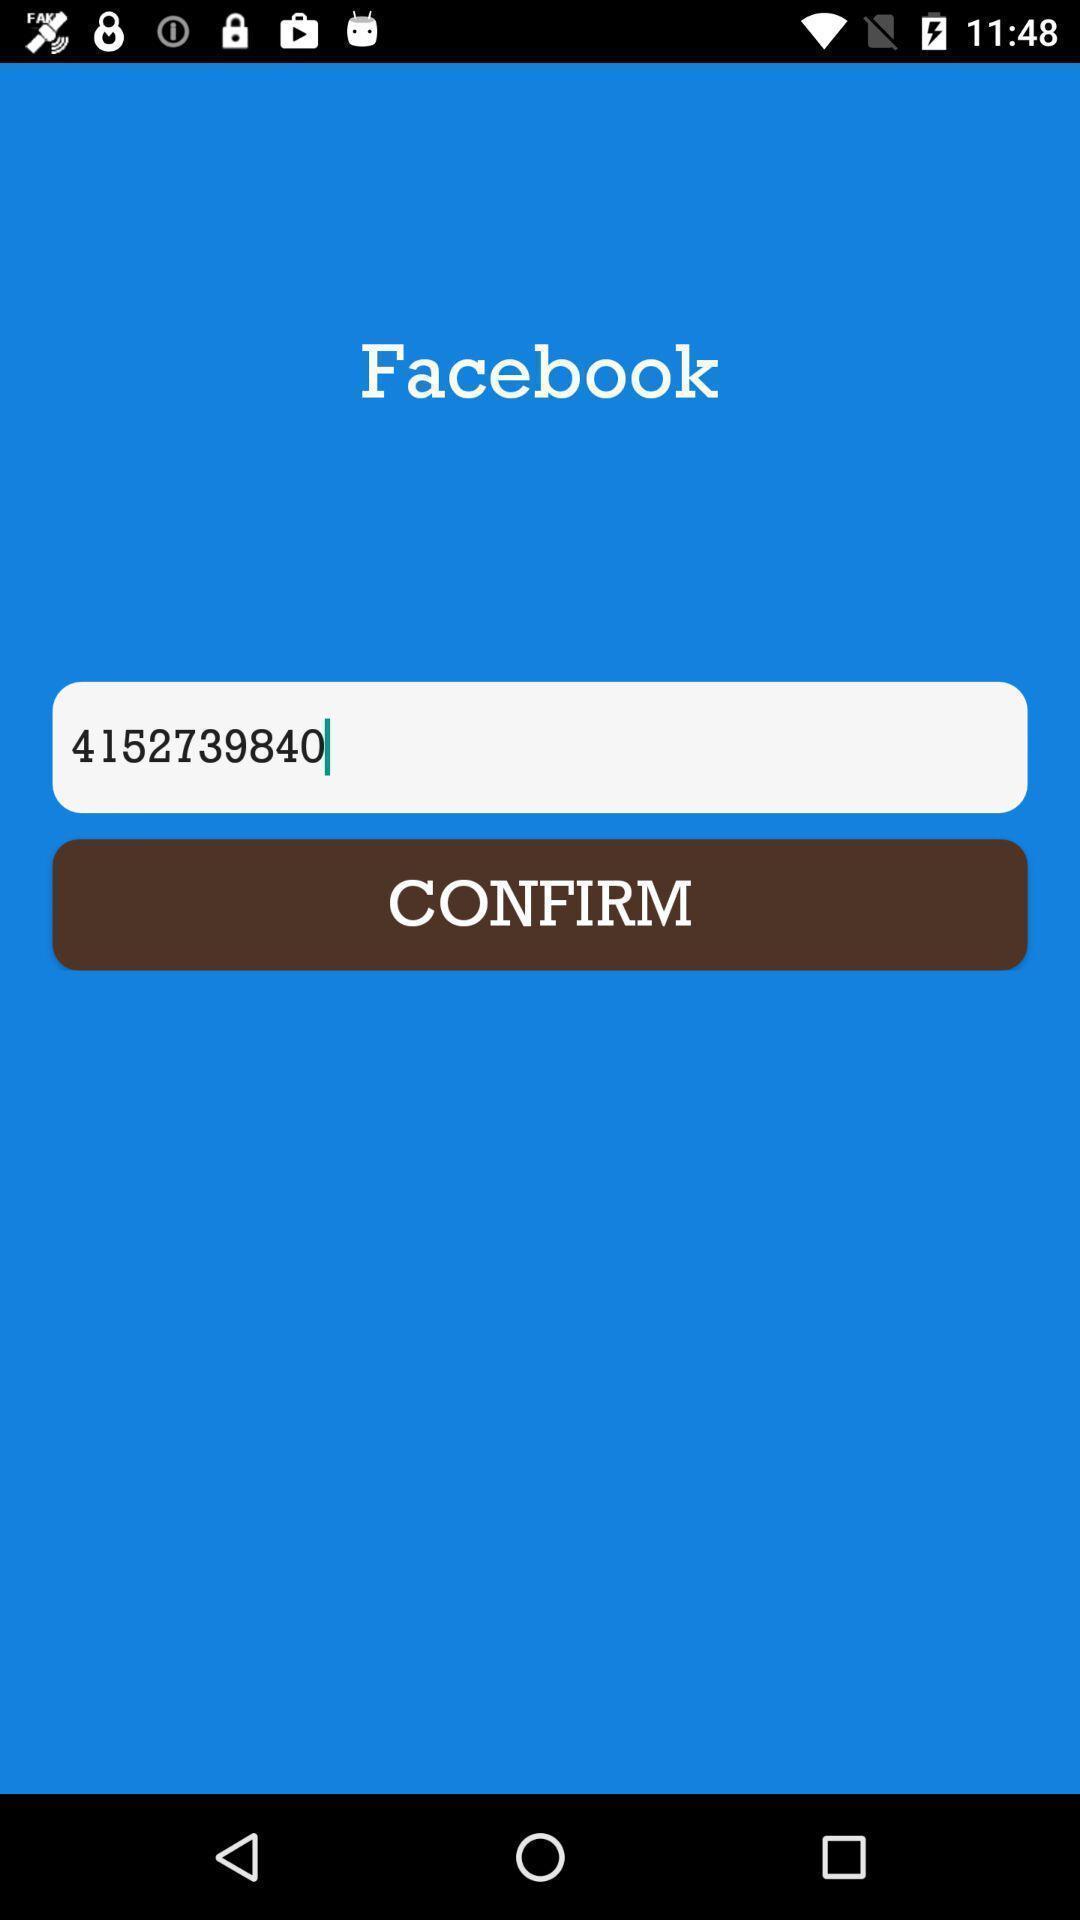Explain the elements present in this screenshot. Window displaying about confirmation page of social app. 